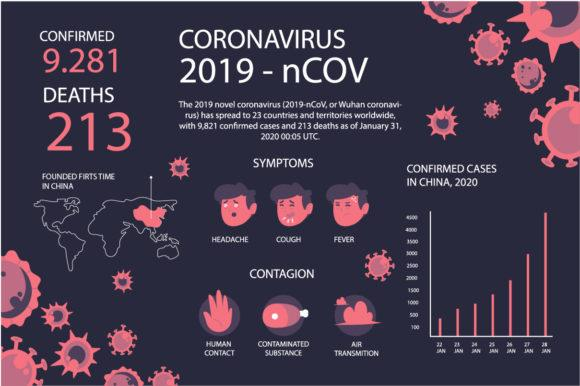Draw attention to some important aspects in this diagram. The confirmed cases of COVID-19 in China reached their highest point in 2020 on January 28, according to the graph. The COVID-19 virus is primarily transmitted through human contact, contaminated substances, and airborne transmission. The symptoms of COVID-19, commonly referred to as coronavirus, include headache, cough, and fever. 